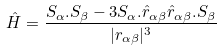Convert formula to latex. <formula><loc_0><loc_0><loc_500><loc_500>\hat { H } = \frac { { S } _ { \alpha } . { S } _ { \beta } - 3 { S } _ { \alpha } . { \hat { r } } _ { \alpha \beta } { \hat { r } } _ { \alpha \beta } . { S } _ { \beta } } { | { r } _ { \alpha \beta } | ^ { 3 } }</formula> 